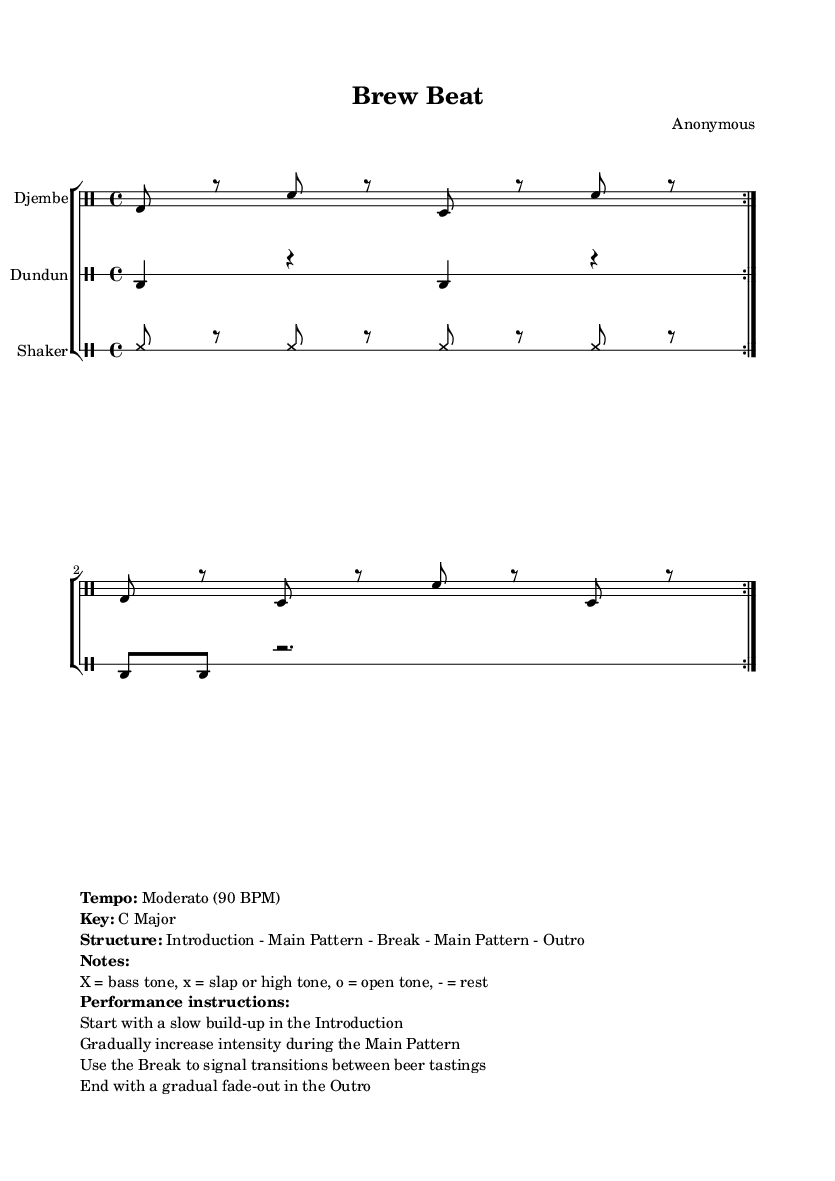What is the time signature of this music? The time signature is indicated at the beginning of the drumming patterns, showing that there are four beats in each measure.
Answer: 4/4 What is the tempo marking of the piece? The tempo marking is presented at the end of the score, showing that the piece should be played at a moderate speed of 90 beats per minute.
Answer: Moderato (90 BPM) How many sections are there in the structure of the music? The structure describes the format and indicates that there are four distinct parts: Introduction, Main Pattern, Break, and Outro.
Answer: Four What types of drums are used in this composition? The score specifies three different instruments: Djembe, Dundun, and Shaker, which are commonly used in traditional African drumming.
Answer: Djembe, Dundun, Shaker What dynamic change occurs during the Main Pattern section? The performance instructions indicate that the intensity should gradually increase during the Main Pattern to build energy.
Answer: Increase intensity What does the Break signify in this context? The Break is mentioned as a transition element that signals the change between different beer tastings, creating a thematic pause in the rhythm.
Answer: Transition between tastings What is the overall key of the piece? The key is given in the markup section, specifying the tonal center of the composition; there are no accidentals suggesting sharps or flats.
Answer: C Major 